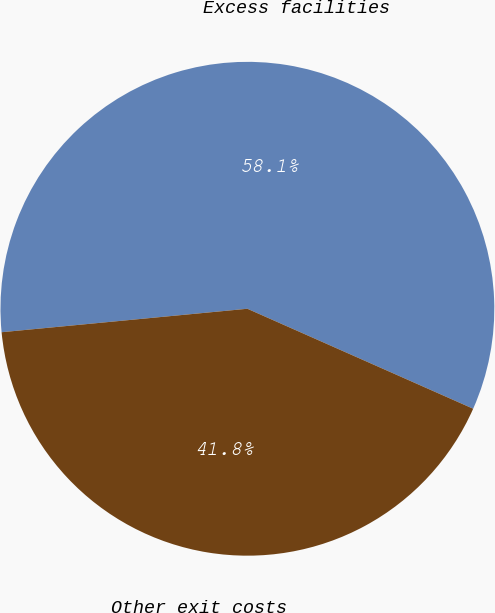Convert chart to OTSL. <chart><loc_0><loc_0><loc_500><loc_500><pie_chart><fcel>Excess facilities<fcel>Other exit costs<nl><fcel>58.15%<fcel>41.85%<nl></chart> 